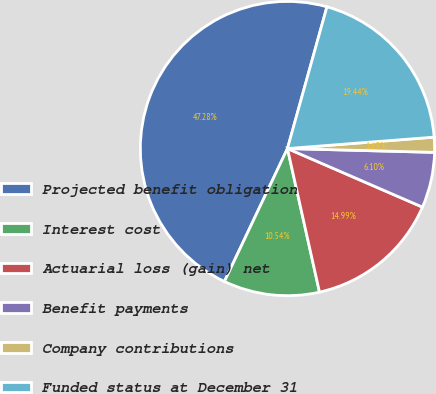<chart> <loc_0><loc_0><loc_500><loc_500><pie_chart><fcel>Projected benefit obligation<fcel>Interest cost<fcel>Actuarial loss (gain) net<fcel>Benefit payments<fcel>Company contributions<fcel>Funded status at December 31<nl><fcel>47.28%<fcel>10.54%<fcel>14.99%<fcel>6.1%<fcel>1.65%<fcel>19.44%<nl></chart> 